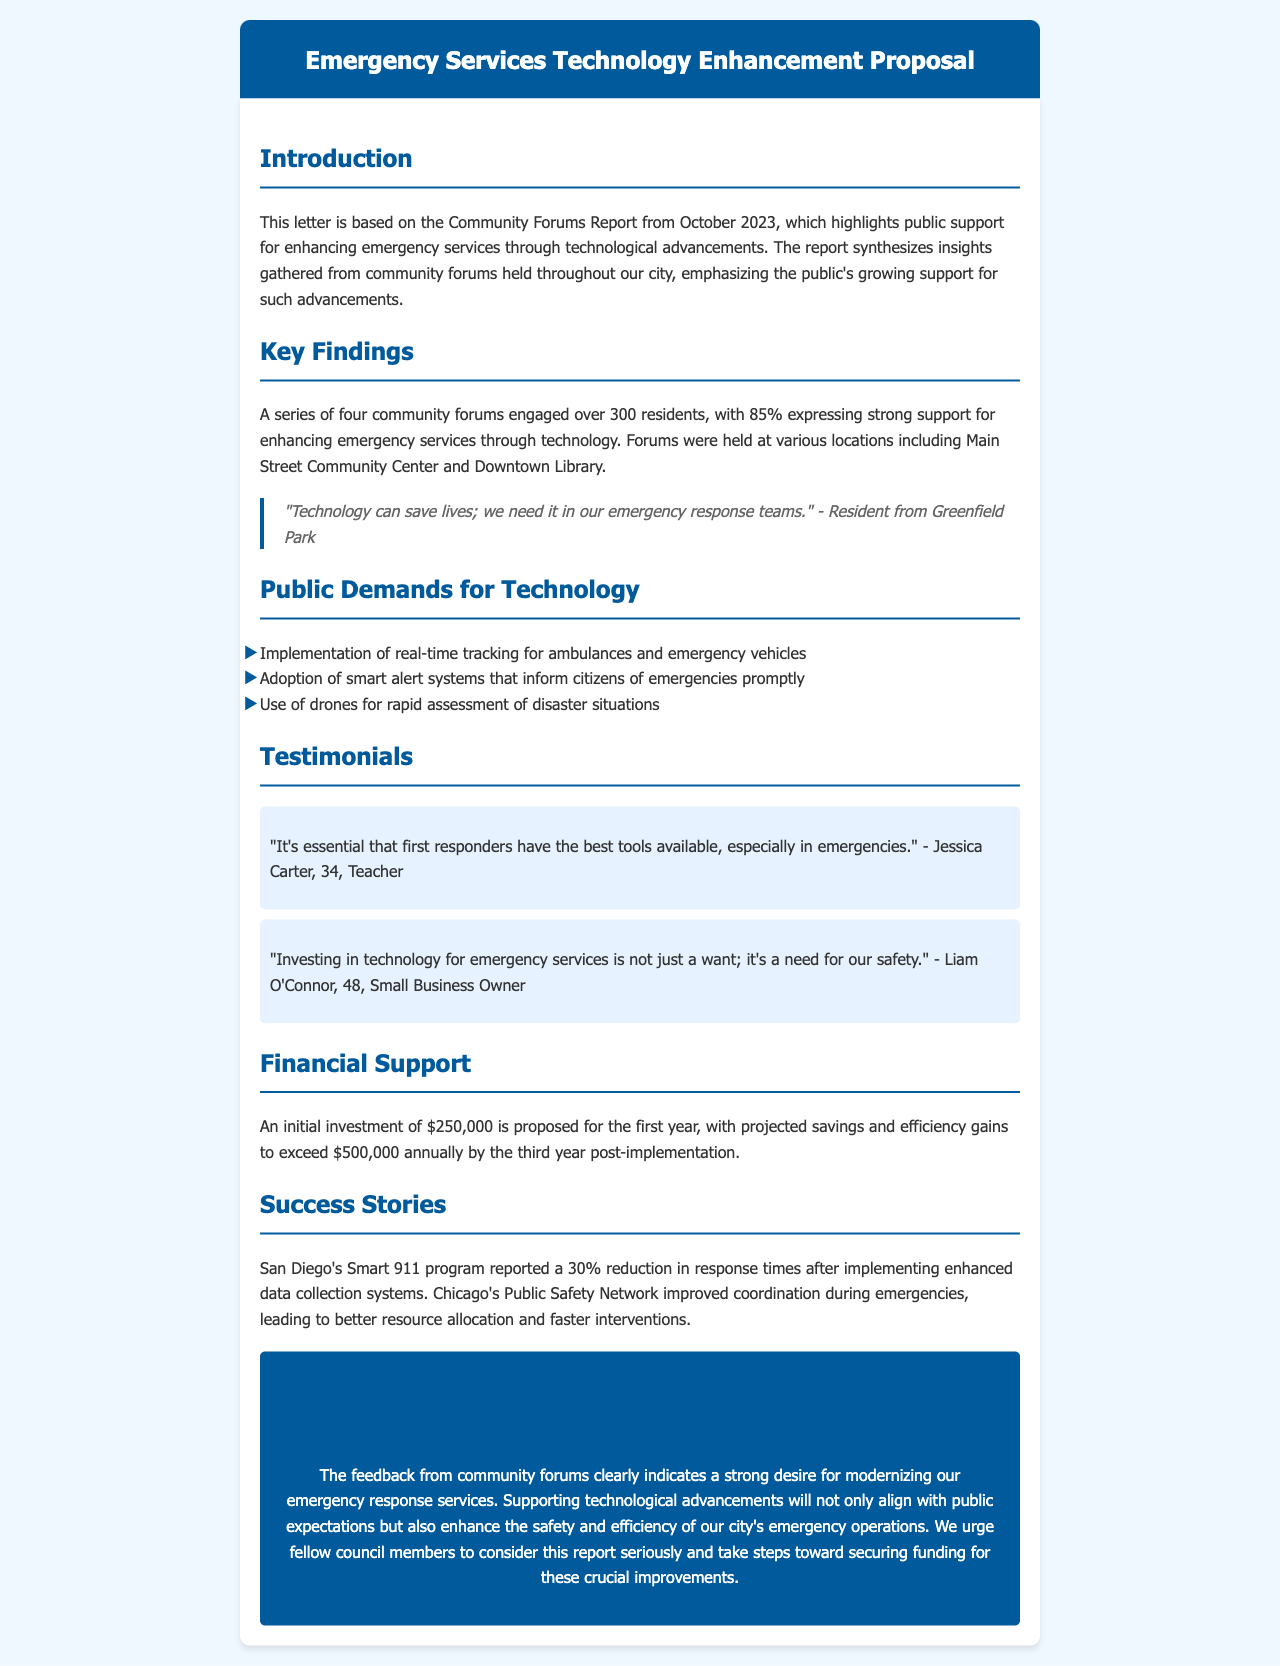What percentage of residents support enhancing emergency services through technology? The document states that 85% of residents expressed strong support for enhancing emergency services through technology.
Answer: 85% What financial investment is proposed for the first year? The letter mentions an initial investment of $250,000 for the first year.
Answer: $250,000 Which community locations hosted the forums? The forums were held at various locations including the Main Street Community Center and Downtown Library.
Answer: Main Street Community Center and Downtown Library What is one technological demand from the public? The document lists several demands; one example is the implementation of real-time tracking for ambulances.
Answer: Real-time tracking for ambulances What success story is highlighted regarding improved response times? The document includes a success story from San Diego's Smart 911 program, which reported a 30% reduction in response times.
Answer: 30% How many residents engaged in the community forums? The report engaged over 300 residents during the community forums.
Answer: 300 What is the projected savings by the third year post-implementation? The document states that projected savings and efficiency gains will exceed $500,000 annually by the third year.
Answer: $500,000 What is the primary purpose of the letter? The letter is aimed at advocating for funding and support for enhancing emergency services through technological advancements in response to community feedback.
Answer: Advocating for funding for enhancing emergency services 